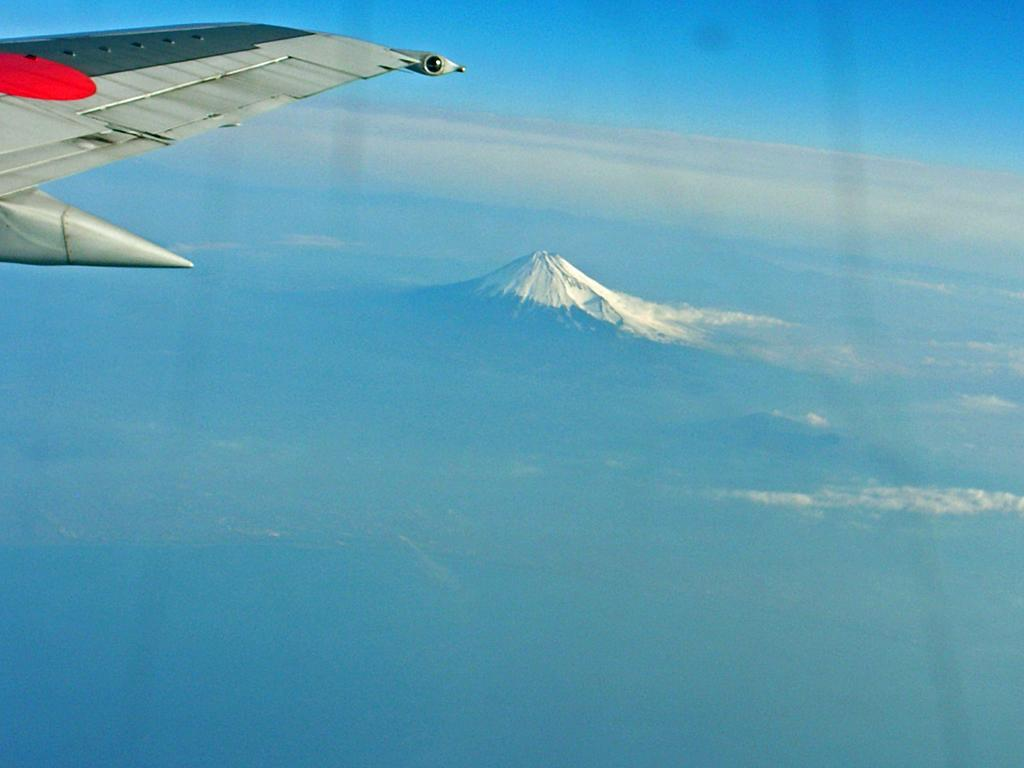What is the main subject of the image? The main subject of the image is an aeroplane wing. What colors can be seen on the wing? The wing is grey, black, and red in color. What is the aeroplane doing in the image? The aeroplane is flying in the air. What can be seen in the background of the image? There is a mountain and the sky visible in the background of the image. What type of meal is being prepared in the image? There is no meal being prepared in the image; it features an aeroplane wing. How does the aeroplane blow air in the image? The aeroplane does not blow air in the image; it is simply flying. 